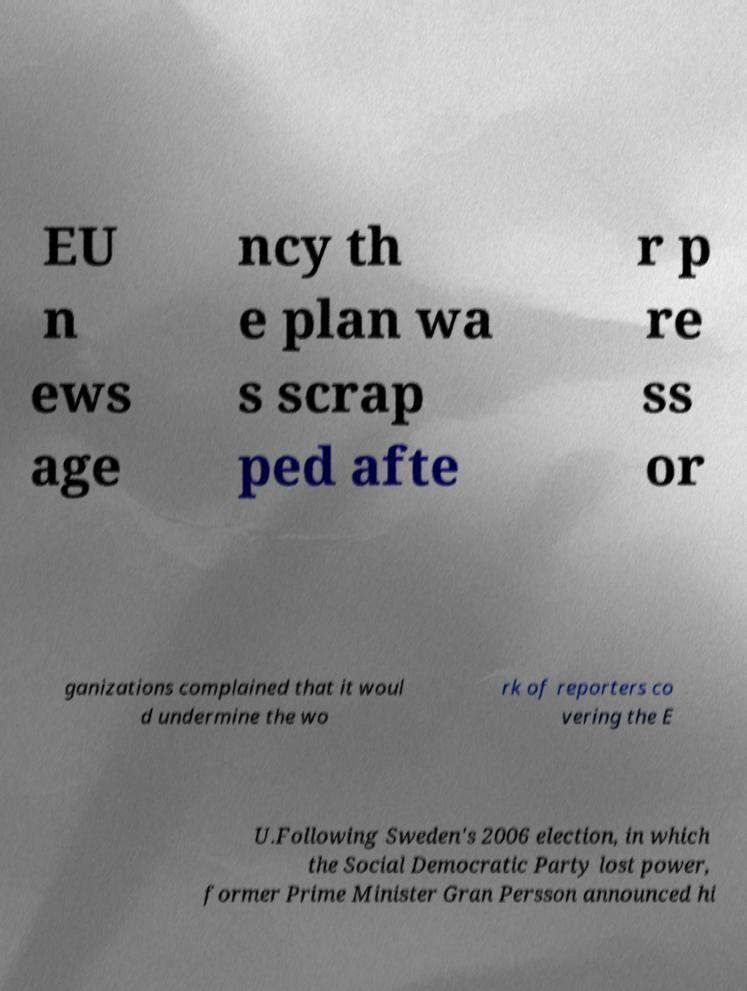I need the written content from this picture converted into text. Can you do that? EU n ews age ncy th e plan wa s scrap ped afte r p re ss or ganizations complained that it woul d undermine the wo rk of reporters co vering the E U.Following Sweden's 2006 election, in which the Social Democratic Party lost power, former Prime Minister Gran Persson announced hi 